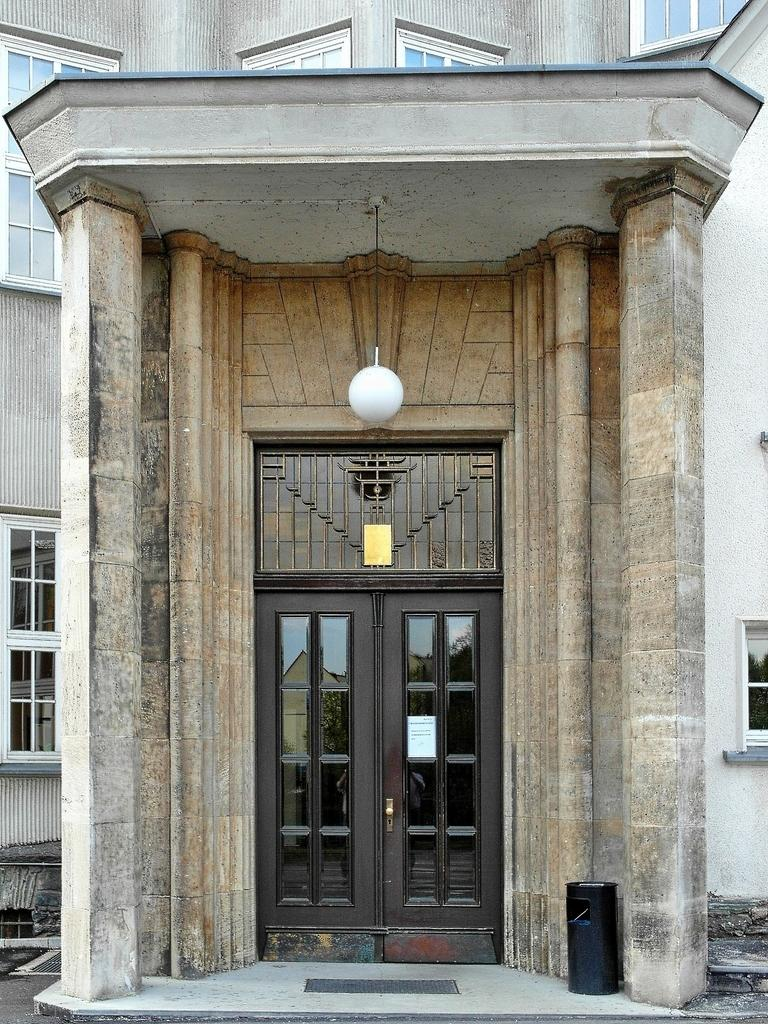What is the main feature of the image? The main feature of the image is an entrance to a building. What is a key component of the entrance? The entrance has a door. What can be seen in addition to the entrance in the image? There are windows visible in the image. What type of lighting is present in the image? There is a light hanging from the ceiling. What color is the object on a surface in the image? There is a black color object on a surface in the image. What type of pollution can be seen in the image? There is no pollution visible in the image. How many cherries are on the black color object in the image? There are no cherries present in the image. 